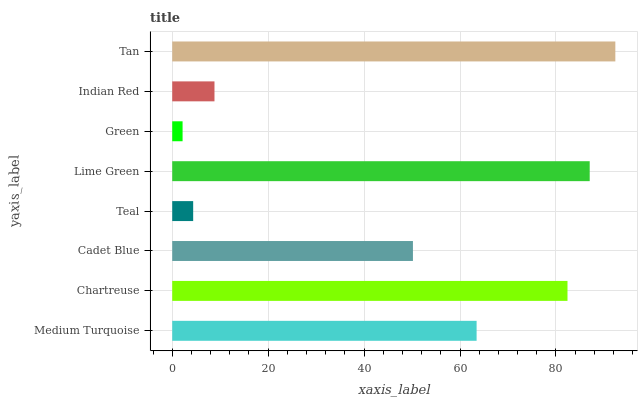Is Green the minimum?
Answer yes or no. Yes. Is Tan the maximum?
Answer yes or no. Yes. Is Chartreuse the minimum?
Answer yes or no. No. Is Chartreuse the maximum?
Answer yes or no. No. Is Chartreuse greater than Medium Turquoise?
Answer yes or no. Yes. Is Medium Turquoise less than Chartreuse?
Answer yes or no. Yes. Is Medium Turquoise greater than Chartreuse?
Answer yes or no. No. Is Chartreuse less than Medium Turquoise?
Answer yes or no. No. Is Medium Turquoise the high median?
Answer yes or no. Yes. Is Cadet Blue the low median?
Answer yes or no. Yes. Is Lime Green the high median?
Answer yes or no. No. Is Chartreuse the low median?
Answer yes or no. No. 